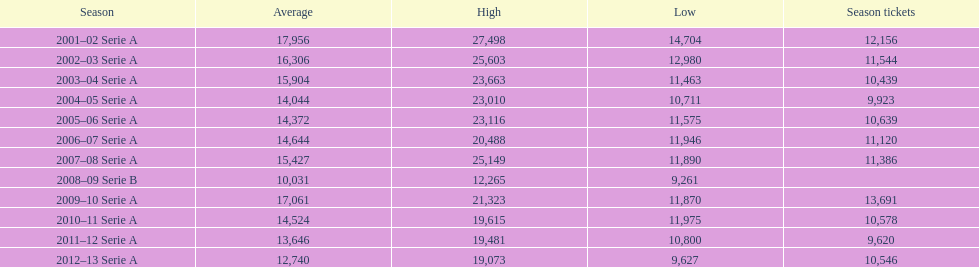What are the various seasons? 2001–02 Serie A, 2002–03 Serie A, 2003–04 Serie A, 2004–05 Serie A, 2005–06 Serie A, 2006–07 Serie A, 2007–08 Serie A, 2008–09 Serie B, 2009–10 Serie A, 2010–11 Serie A, 2011–12 Serie A, 2012–13 Serie A. In 2007, which season took place? 2007–08 Serie A. Throughout that season, how many season tickets were bought? 11,386. 